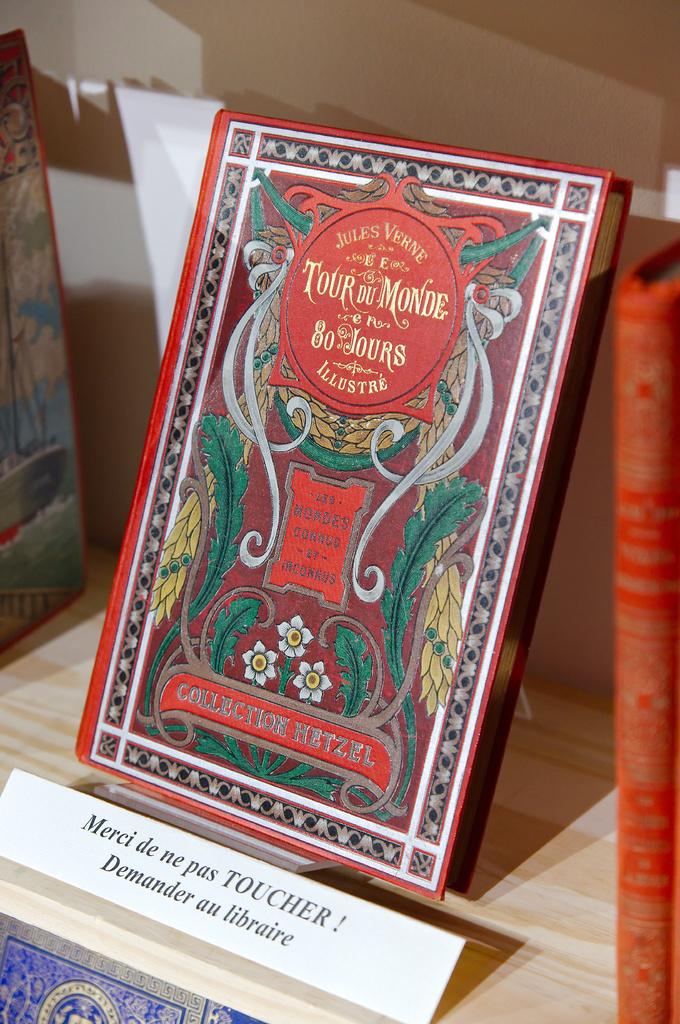Who is the author of the book?
Make the answer very short. Jules verne. What number is on the book?
Give a very brief answer. 80. 